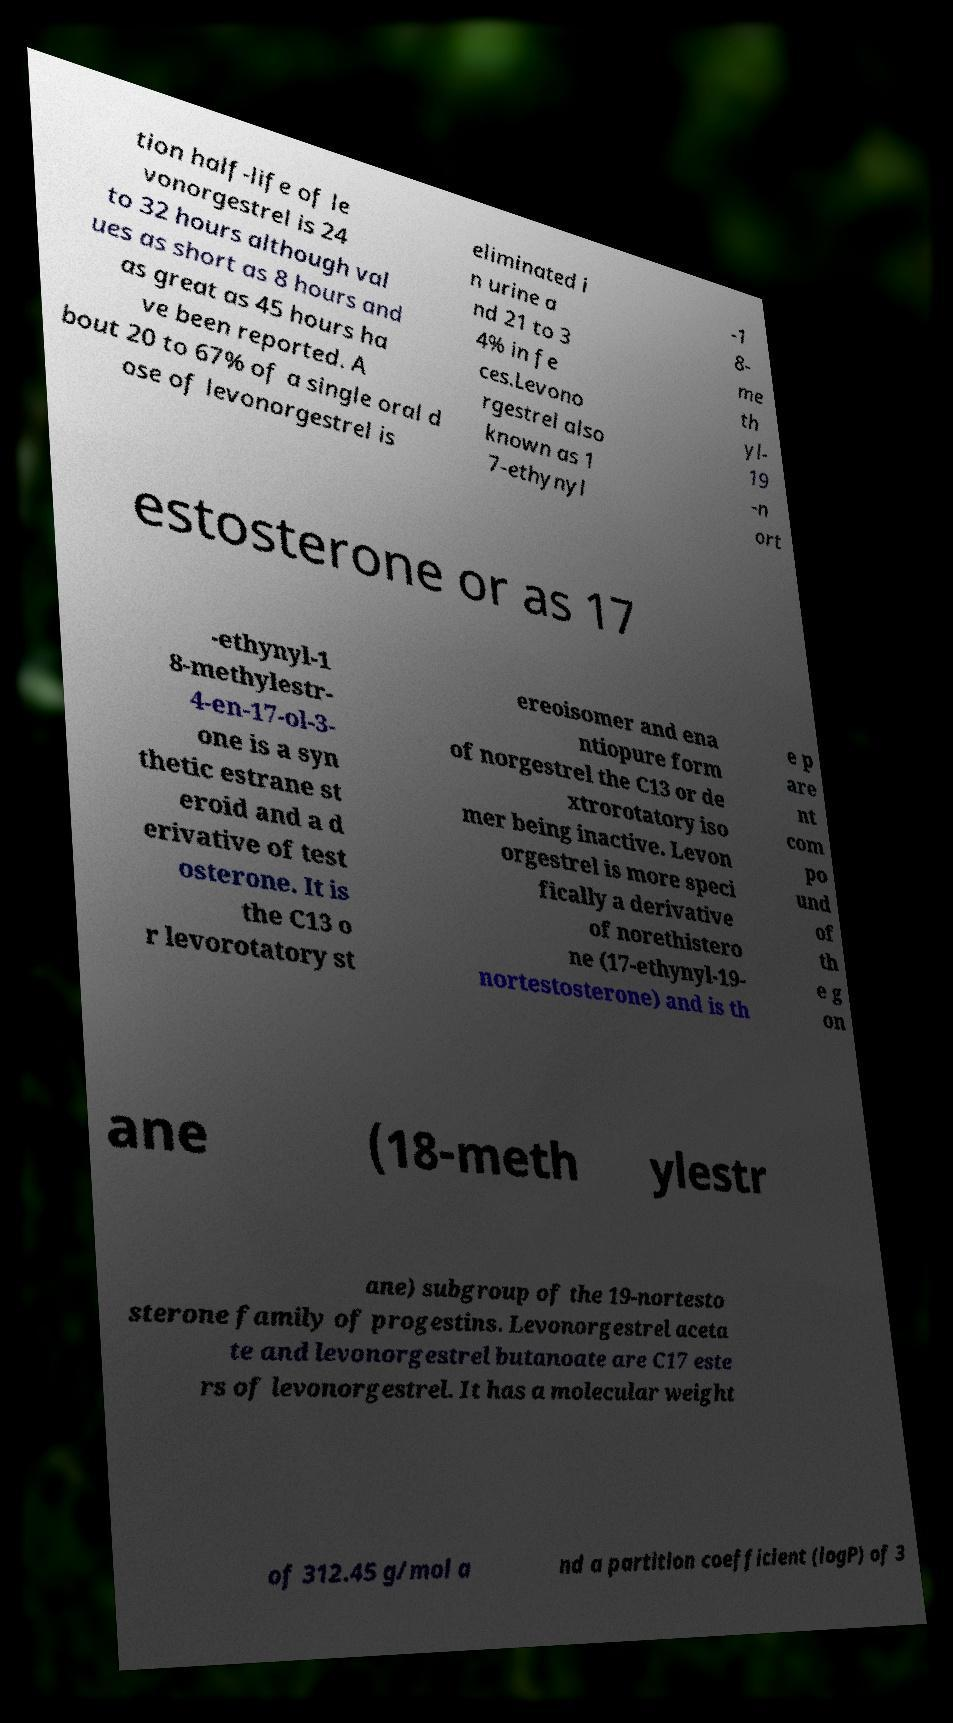Please identify and transcribe the text found in this image. tion half-life of le vonorgestrel is 24 to 32 hours although val ues as short as 8 hours and as great as 45 hours ha ve been reported. A bout 20 to 67% of a single oral d ose of levonorgestrel is eliminated i n urine a nd 21 to 3 4% in fe ces.Levono rgestrel also known as 1 7-ethynyl -1 8- me th yl- 19 -n ort estosterone or as 17 -ethynyl-1 8-methylestr- 4-en-17-ol-3- one is a syn thetic estrane st eroid and a d erivative of test osterone. It is the C13 o r levorotatory st ereoisomer and ena ntiopure form of norgestrel the C13 or de xtrorotatory iso mer being inactive. Levon orgestrel is more speci fically a derivative of norethistero ne (17-ethynyl-19- nortestosterone) and is th e p are nt com po und of th e g on ane (18-meth ylestr ane) subgroup of the 19-nortesto sterone family of progestins. Levonorgestrel aceta te and levonorgestrel butanoate are C17 este rs of levonorgestrel. It has a molecular weight of 312.45 g/mol a nd a partition coefficient (logP) of 3 